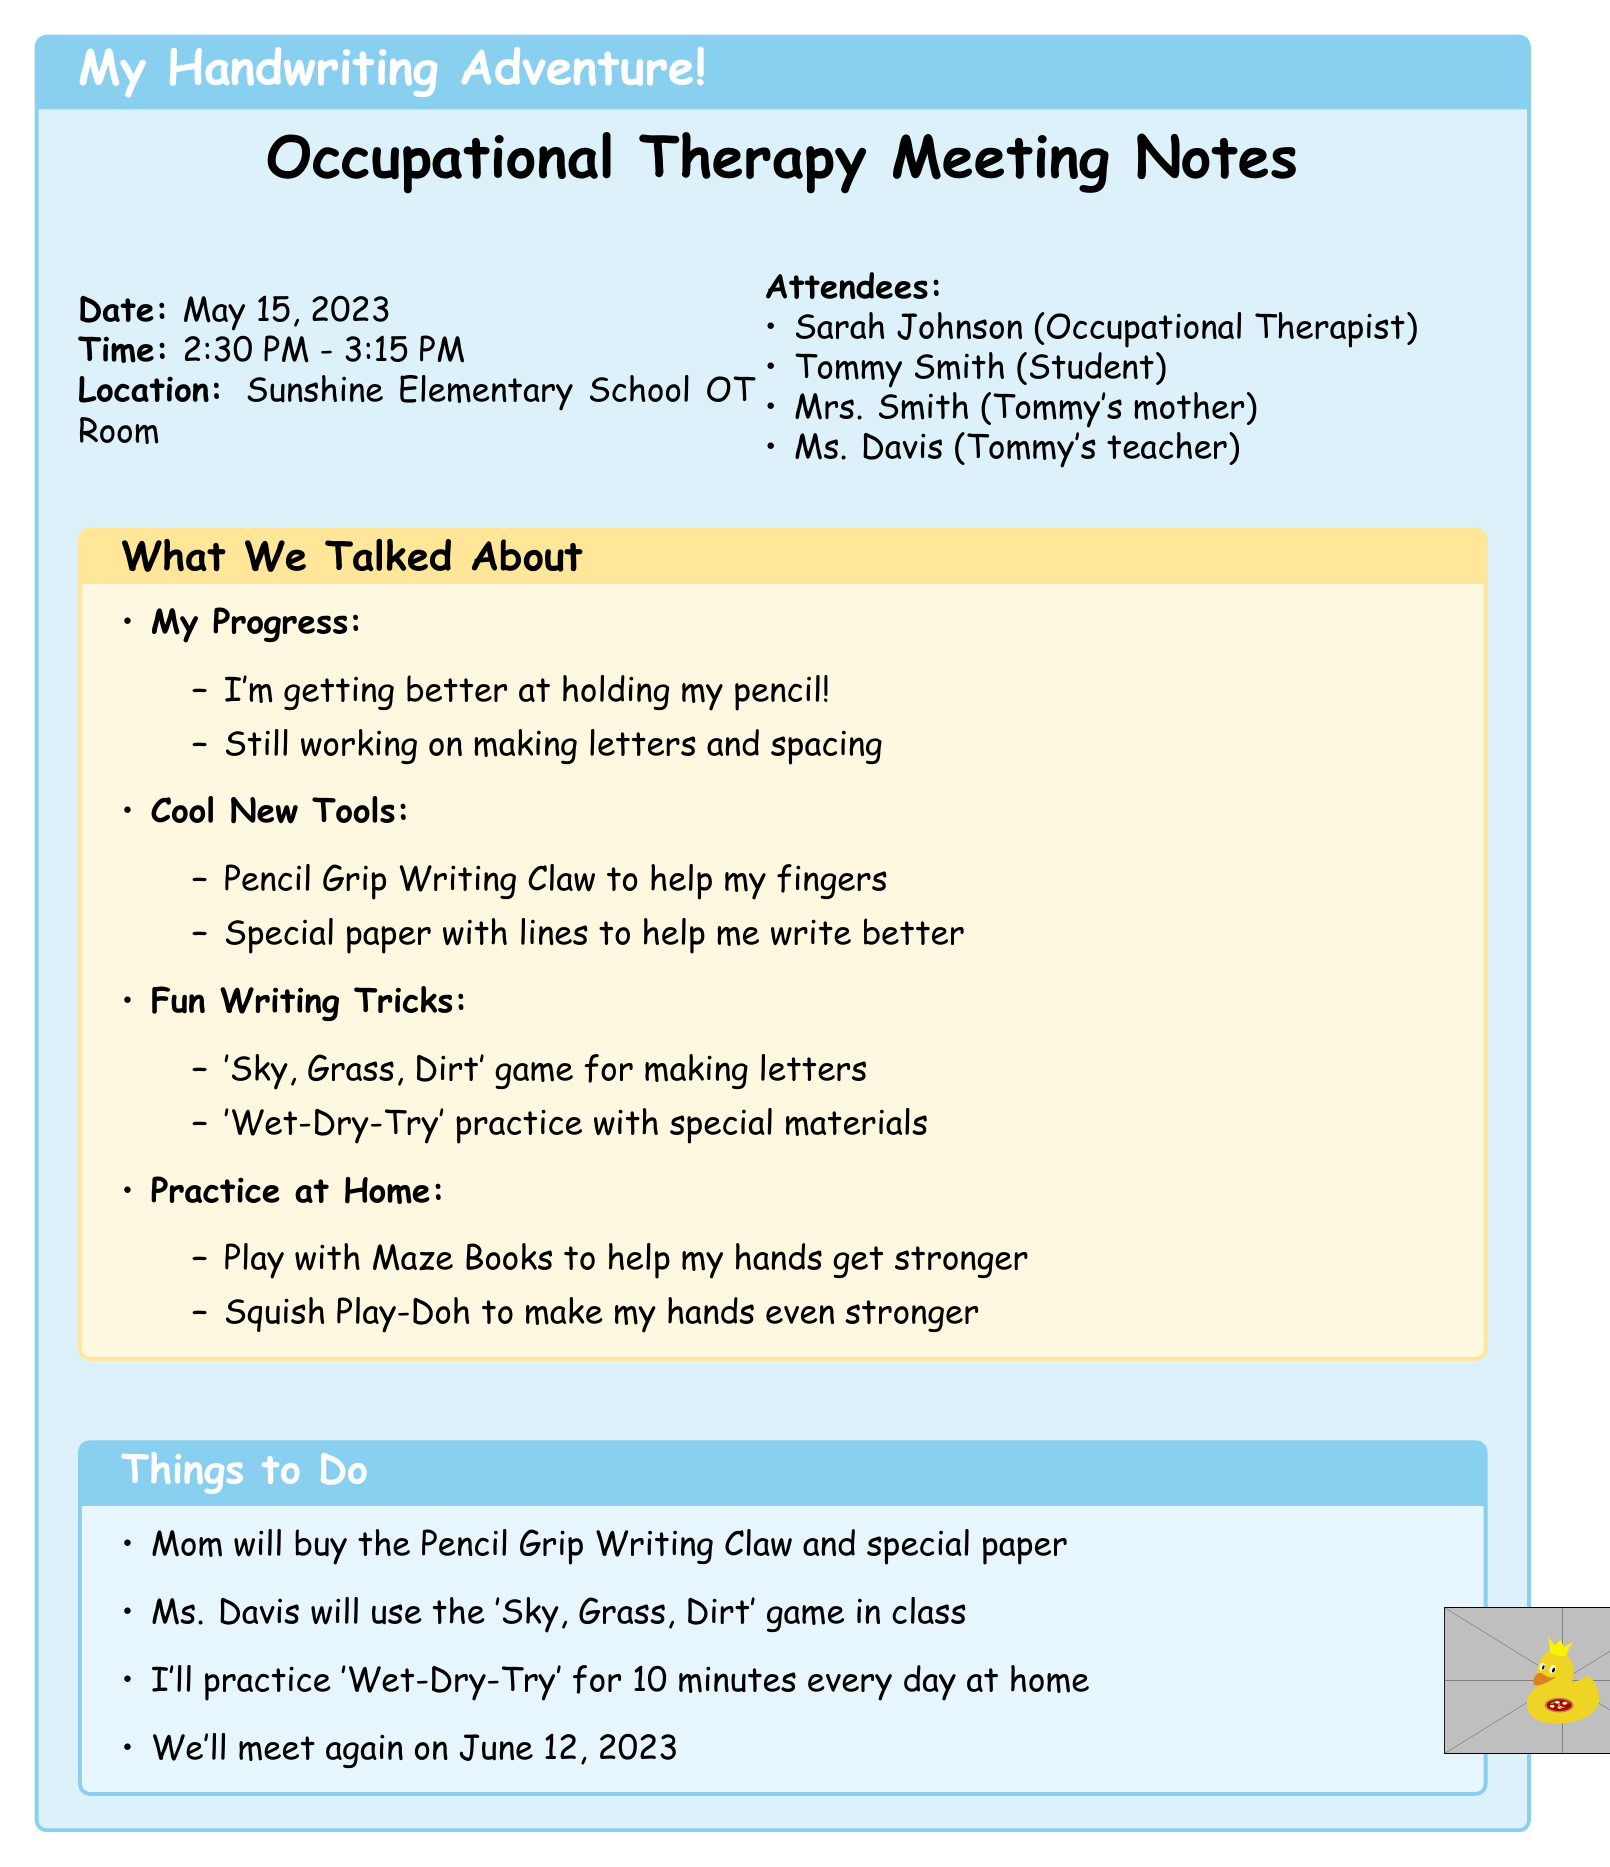What is the date of the meeting? The date is mentioned in the meeting details section of the document as May 15, 2023.
Answer: May 15, 2023 Who is the occupational therapist? The occupational therapist's name is listed in the attendees section of the document as Sarah Johnson.
Answer: Sarah Johnson What handwriting method was introduced during the session? The document highlights new handwriting techniques, specifically mentioning the 'Sky, Grass, Dirt' method.
Answer: 'Sky, Grass, Dirt' How long should Tommy practice the 'Wet-Dry-Try' technique at home? According to the action items, Tommy is advised to practice for 10 minutes daily.
Answer: 10 minutes What tool will Mrs. Smith purchase? The action items specify that Mrs. Smith will buy the Pencil Grip Writing Claw and raised line paper.
Answer: Pencil Grip Writing Claw and raised line paper What is the location of the occupational therapy meeting? The location is stated in the meeting details as Sunshine Elementary School OT Room.
Answer: Sunshine Elementary School OT Room Who will incorporate the new method in classroom activities? The document indicates that Ms. Davis will include the 'Sky, Grass, Dirt' method in classroom activities.
Answer: Ms. Davis When is the follow-up session scheduled? The follow-up session is noted in the action items as scheduled for June 12, 2023.
Answer: June 12, 2023 